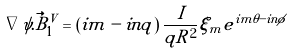<formula> <loc_0><loc_0><loc_500><loc_500>\nabla \psi . \vec { B } _ { 1 } ^ { V } = \left ( i m - i n q \right ) \frac { I } { q R ^ { 2 } } \xi _ { m } e ^ { i m \theta - i n \phi }</formula> 